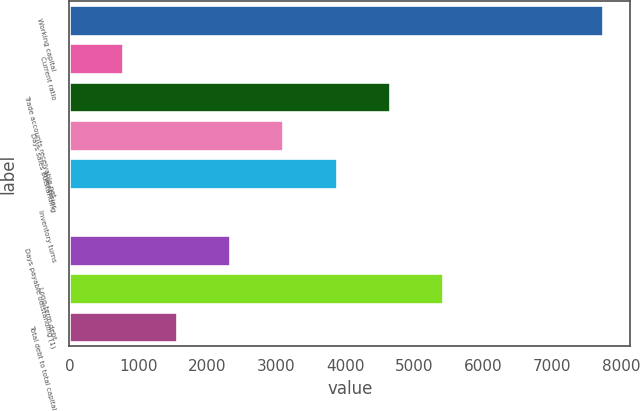<chart> <loc_0><loc_0><loc_500><loc_500><bar_chart><fcel>Working capital<fcel>Current ratio<fcel>Trade accounts receivable net<fcel>Days sales outstanding<fcel>Inventories<fcel>Inventory turns<fcel>Days payable outstanding (1)<fcel>Long-term debt<fcel>Total debt to total capital<nl><fcel>7739<fcel>778.13<fcel>4645.28<fcel>3098.42<fcel>3871.85<fcel>4.7<fcel>2324.99<fcel>5418.71<fcel>1551.56<nl></chart> 